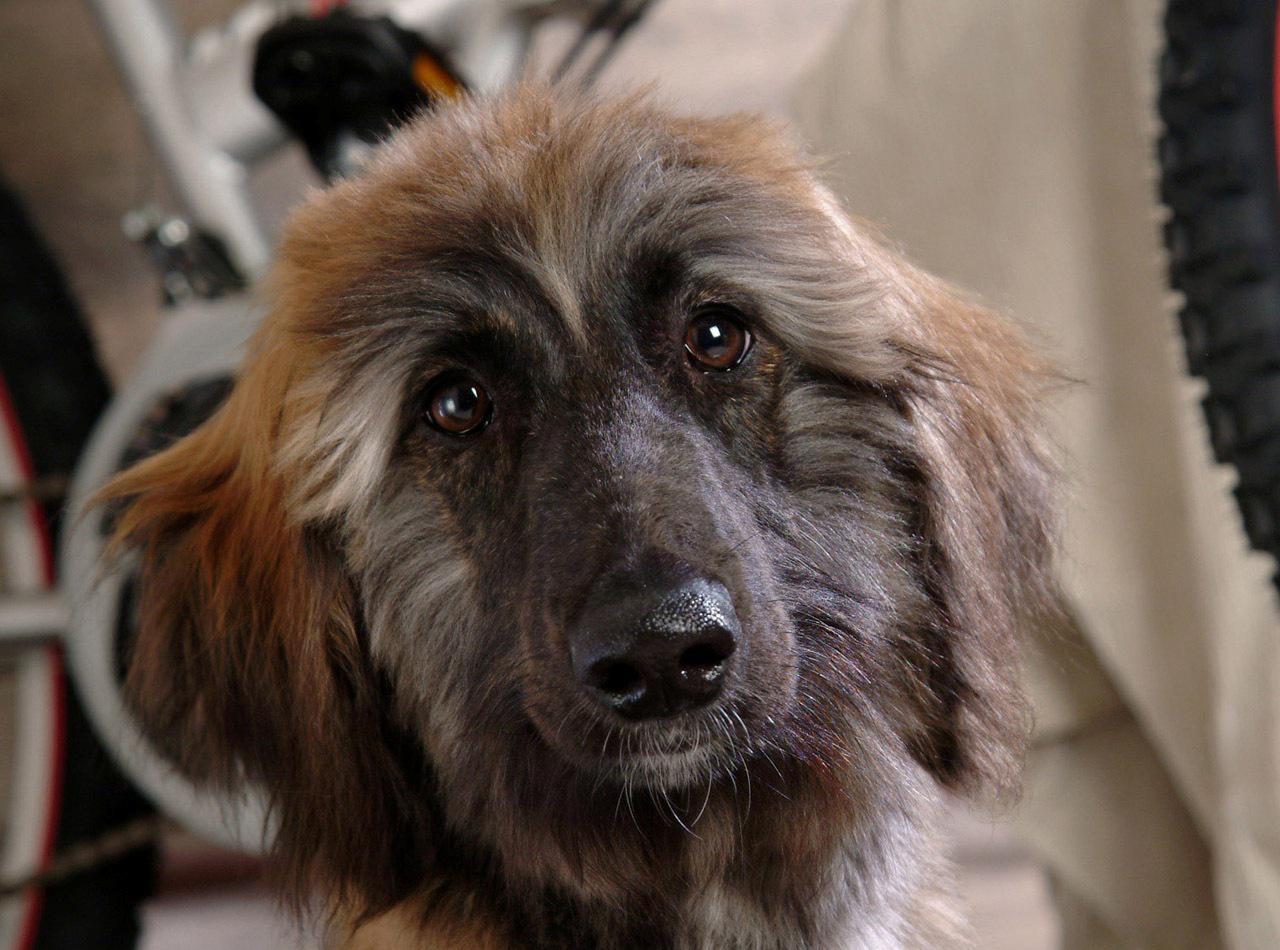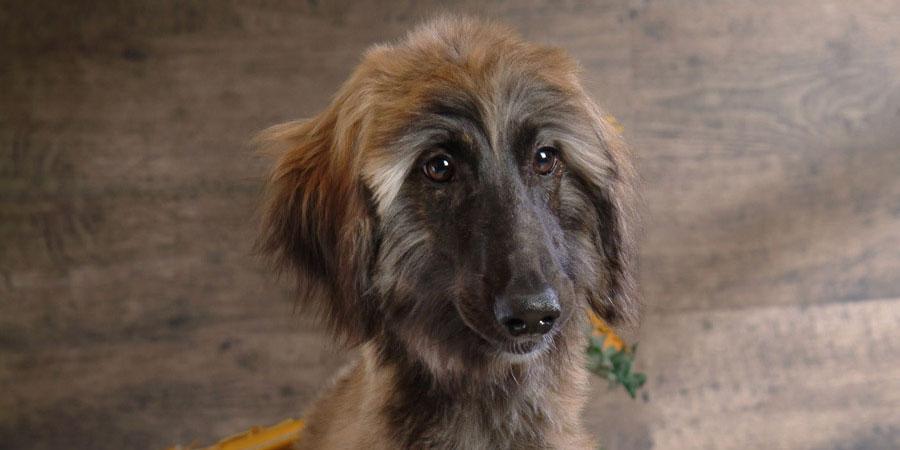The first image is the image on the left, the second image is the image on the right. Considering the images on both sides, is "One image contains at least five dogs, with varying fur coloration." valid? Answer yes or no. No. The first image is the image on the left, the second image is the image on the right. Analyze the images presented: Is the assertion "There is a group of dogs in one of the images." valid? Answer yes or no. No. 